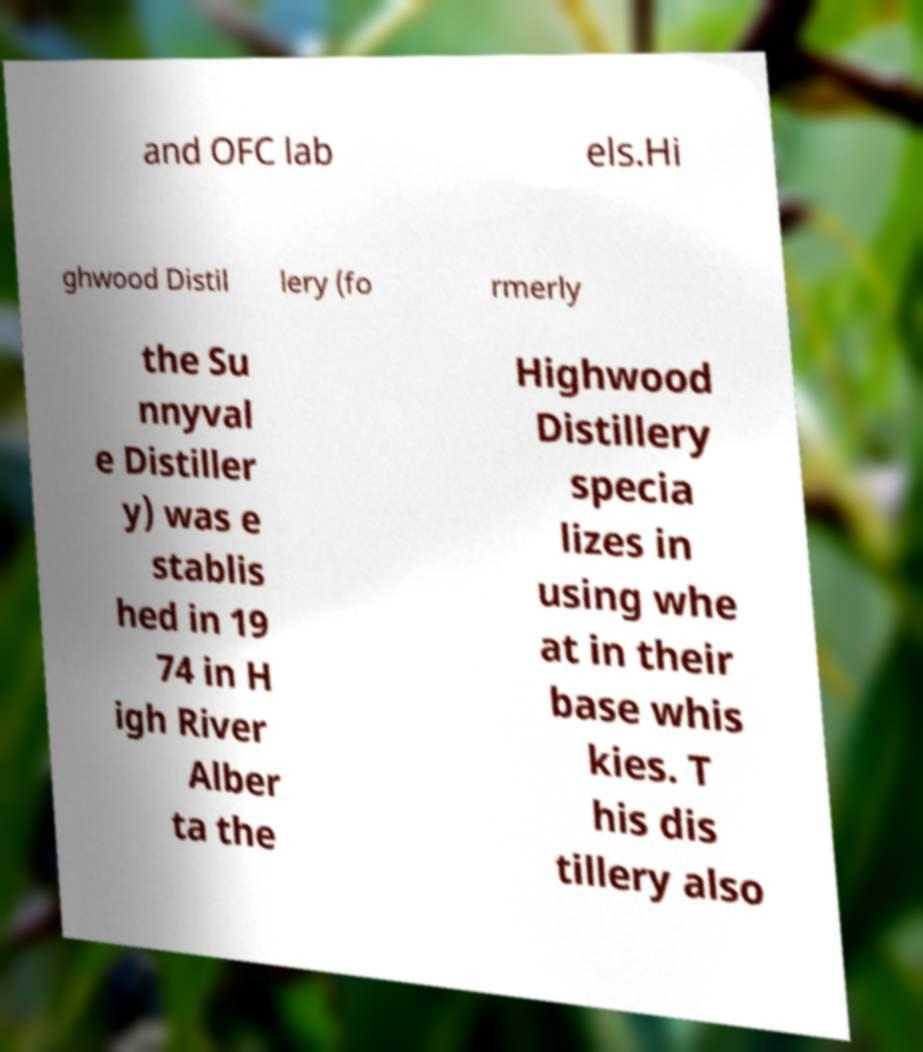Please read and relay the text visible in this image. What does it say? and OFC lab els.Hi ghwood Distil lery (fo rmerly the Su nnyval e Distiller y) was e stablis hed in 19 74 in H igh River Alber ta the Highwood Distillery specia lizes in using whe at in their base whis kies. T his dis tillery also 